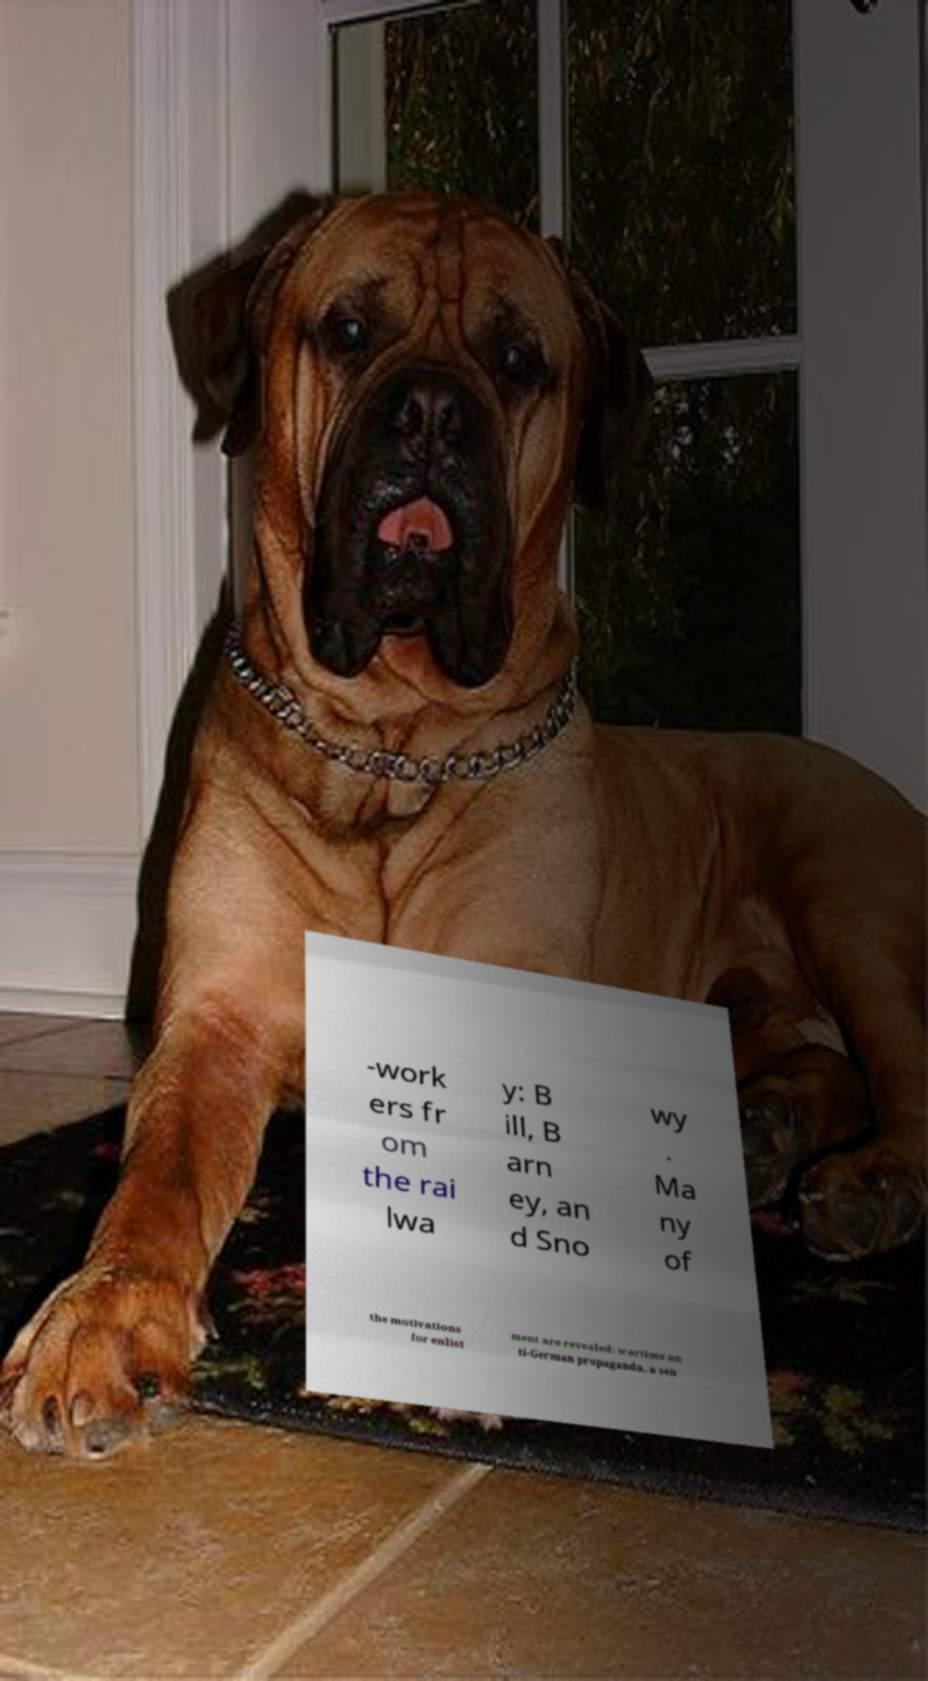What messages or text are displayed in this image? I need them in a readable, typed format. -work ers fr om the rai lwa y: B ill, B arn ey, an d Sno wy . Ma ny of the motivations for enlist ment are revealed: wartime an ti-German propaganda, a sen 